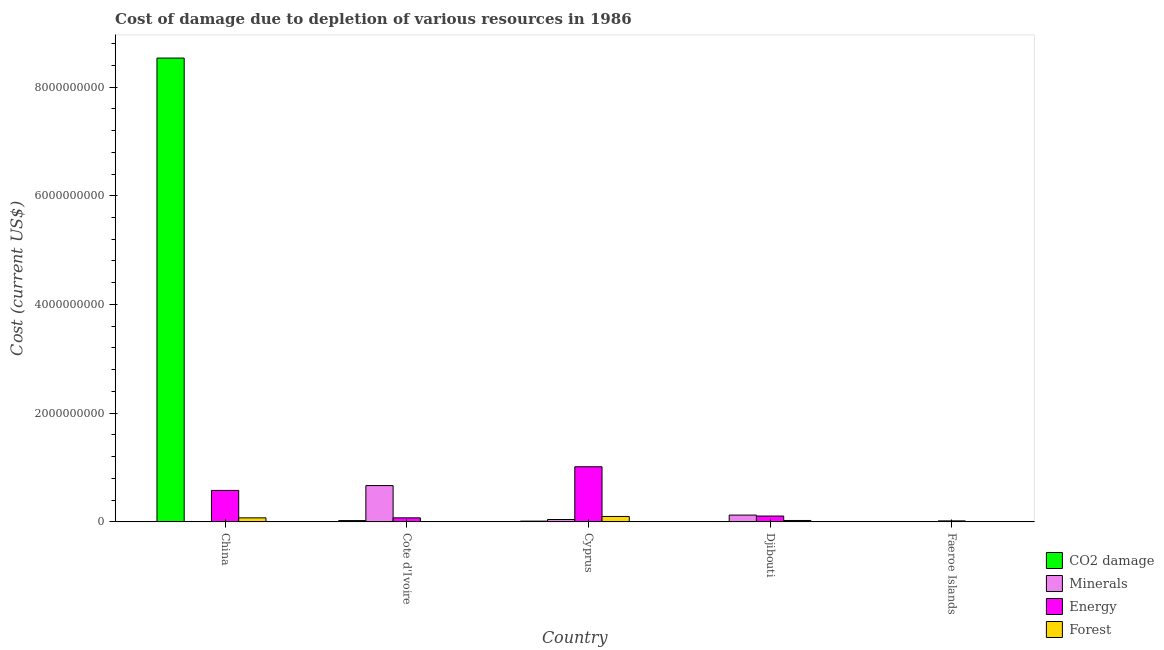How many different coloured bars are there?
Offer a terse response. 4. Are the number of bars on each tick of the X-axis equal?
Make the answer very short. Yes. What is the label of the 2nd group of bars from the left?
Offer a very short reply. Cote d'Ivoire. In how many cases, is the number of bars for a given country not equal to the number of legend labels?
Your answer should be compact. 0. What is the cost of damage due to depletion of minerals in Cote d'Ivoire?
Make the answer very short. 6.69e+08. Across all countries, what is the maximum cost of damage due to depletion of coal?
Your answer should be very brief. 8.53e+09. Across all countries, what is the minimum cost of damage due to depletion of energy?
Keep it short and to the point. 1.89e+07. In which country was the cost of damage due to depletion of minerals maximum?
Your answer should be compact. Cote d'Ivoire. In which country was the cost of damage due to depletion of energy minimum?
Make the answer very short. Faeroe Islands. What is the total cost of damage due to depletion of energy in the graph?
Make the answer very short. 1.80e+09. What is the difference between the cost of damage due to depletion of energy in Cote d'Ivoire and that in Cyprus?
Offer a terse response. -9.40e+08. What is the difference between the cost of damage due to depletion of forests in China and the cost of damage due to depletion of energy in Faeroe Islands?
Your answer should be compact. 5.60e+07. What is the average cost of damage due to depletion of forests per country?
Make the answer very short. 4.16e+07. What is the difference between the cost of damage due to depletion of minerals and cost of damage due to depletion of forests in China?
Offer a terse response. -7.49e+07. What is the ratio of the cost of damage due to depletion of forests in China to that in Faeroe Islands?
Offer a terse response. 11.75. Is the cost of damage due to depletion of energy in China less than that in Faeroe Islands?
Your response must be concise. No. Is the difference between the cost of damage due to depletion of energy in China and Faeroe Islands greater than the difference between the cost of damage due to depletion of coal in China and Faeroe Islands?
Keep it short and to the point. No. What is the difference between the highest and the second highest cost of damage due to depletion of minerals?
Provide a succinct answer. 5.43e+08. What is the difference between the highest and the lowest cost of damage due to depletion of coal?
Offer a terse response. 8.53e+09. In how many countries, is the cost of damage due to depletion of minerals greater than the average cost of damage due to depletion of minerals taken over all countries?
Keep it short and to the point. 1. Is the sum of the cost of damage due to depletion of coal in China and Cyprus greater than the maximum cost of damage due to depletion of forests across all countries?
Ensure brevity in your answer.  Yes. Is it the case that in every country, the sum of the cost of damage due to depletion of coal and cost of damage due to depletion of minerals is greater than the sum of cost of damage due to depletion of energy and cost of damage due to depletion of forests?
Offer a very short reply. No. What does the 1st bar from the left in Djibouti represents?
Your response must be concise. CO2 damage. What does the 2nd bar from the right in China represents?
Keep it short and to the point. Energy. Is it the case that in every country, the sum of the cost of damage due to depletion of coal and cost of damage due to depletion of minerals is greater than the cost of damage due to depletion of energy?
Your answer should be compact. No. How many countries are there in the graph?
Give a very brief answer. 5. What is the difference between two consecutive major ticks on the Y-axis?
Provide a succinct answer. 2.00e+09. Does the graph contain any zero values?
Your response must be concise. No. Where does the legend appear in the graph?
Make the answer very short. Bottom right. What is the title of the graph?
Provide a succinct answer. Cost of damage due to depletion of various resources in 1986 . Does "Finland" appear as one of the legend labels in the graph?
Your response must be concise. No. What is the label or title of the Y-axis?
Offer a terse response. Cost (current US$). What is the Cost (current US$) of CO2 damage in China?
Offer a very short reply. 8.53e+09. What is the Cost (current US$) in Minerals in China?
Keep it short and to the point. 1.22e+04. What is the Cost (current US$) in Energy in China?
Ensure brevity in your answer.  5.79e+08. What is the Cost (current US$) of Forest in China?
Make the answer very short. 7.49e+07. What is the Cost (current US$) in CO2 damage in Cote d'Ivoire?
Offer a terse response. 2.46e+07. What is the Cost (current US$) in Minerals in Cote d'Ivoire?
Offer a terse response. 6.69e+08. What is the Cost (current US$) of Energy in Cote d'Ivoire?
Provide a short and direct response. 7.51e+07. What is the Cost (current US$) of Forest in Cote d'Ivoire?
Your answer should be compact. 6.18e+04. What is the Cost (current US$) of CO2 damage in Cyprus?
Make the answer very short. 1.46e+07. What is the Cost (current US$) in Minerals in Cyprus?
Keep it short and to the point. 4.44e+07. What is the Cost (current US$) in Energy in Cyprus?
Ensure brevity in your answer.  1.01e+09. What is the Cost (current US$) of Forest in Cyprus?
Give a very brief answer. 1.00e+08. What is the Cost (current US$) of CO2 damage in Djibouti?
Make the answer very short. 1.56e+06. What is the Cost (current US$) of Minerals in Djibouti?
Your answer should be very brief. 1.26e+08. What is the Cost (current US$) of Energy in Djibouti?
Offer a very short reply. 1.08e+08. What is the Cost (current US$) in Forest in Djibouti?
Make the answer very short. 2.64e+07. What is the Cost (current US$) in CO2 damage in Faeroe Islands?
Your answer should be very brief. 2.03e+06. What is the Cost (current US$) in Minerals in Faeroe Islands?
Offer a very short reply. 7.62e+05. What is the Cost (current US$) in Energy in Faeroe Islands?
Your answer should be very brief. 1.89e+07. What is the Cost (current US$) of Forest in Faeroe Islands?
Your answer should be very brief. 6.37e+06. Across all countries, what is the maximum Cost (current US$) in CO2 damage?
Give a very brief answer. 8.53e+09. Across all countries, what is the maximum Cost (current US$) in Minerals?
Offer a terse response. 6.69e+08. Across all countries, what is the maximum Cost (current US$) of Energy?
Provide a short and direct response. 1.01e+09. Across all countries, what is the maximum Cost (current US$) in Forest?
Keep it short and to the point. 1.00e+08. Across all countries, what is the minimum Cost (current US$) of CO2 damage?
Your answer should be compact. 1.56e+06. Across all countries, what is the minimum Cost (current US$) of Minerals?
Offer a very short reply. 1.22e+04. Across all countries, what is the minimum Cost (current US$) of Energy?
Offer a very short reply. 1.89e+07. Across all countries, what is the minimum Cost (current US$) in Forest?
Offer a very short reply. 6.18e+04. What is the total Cost (current US$) of CO2 damage in the graph?
Provide a succinct answer. 8.58e+09. What is the total Cost (current US$) of Minerals in the graph?
Offer a terse response. 8.40e+08. What is the total Cost (current US$) of Energy in the graph?
Provide a short and direct response. 1.80e+09. What is the total Cost (current US$) in Forest in the graph?
Your response must be concise. 2.08e+08. What is the difference between the Cost (current US$) in CO2 damage in China and that in Cote d'Ivoire?
Provide a short and direct response. 8.51e+09. What is the difference between the Cost (current US$) in Minerals in China and that in Cote d'Ivoire?
Provide a short and direct response. -6.69e+08. What is the difference between the Cost (current US$) in Energy in China and that in Cote d'Ivoire?
Offer a terse response. 5.04e+08. What is the difference between the Cost (current US$) of Forest in China and that in Cote d'Ivoire?
Provide a succinct answer. 7.48e+07. What is the difference between the Cost (current US$) of CO2 damage in China and that in Cyprus?
Offer a terse response. 8.52e+09. What is the difference between the Cost (current US$) of Minerals in China and that in Cyprus?
Provide a short and direct response. -4.44e+07. What is the difference between the Cost (current US$) in Energy in China and that in Cyprus?
Provide a short and direct response. -4.35e+08. What is the difference between the Cost (current US$) in Forest in China and that in Cyprus?
Give a very brief answer. -2.56e+07. What is the difference between the Cost (current US$) of CO2 damage in China and that in Djibouti?
Provide a succinct answer. 8.53e+09. What is the difference between the Cost (current US$) in Minerals in China and that in Djibouti?
Offer a very short reply. -1.26e+08. What is the difference between the Cost (current US$) in Energy in China and that in Djibouti?
Your answer should be very brief. 4.71e+08. What is the difference between the Cost (current US$) in Forest in China and that in Djibouti?
Provide a short and direct response. 4.85e+07. What is the difference between the Cost (current US$) of CO2 damage in China and that in Faeroe Islands?
Offer a very short reply. 8.53e+09. What is the difference between the Cost (current US$) in Minerals in China and that in Faeroe Islands?
Your response must be concise. -7.50e+05. What is the difference between the Cost (current US$) of Energy in China and that in Faeroe Islands?
Provide a succinct answer. 5.61e+08. What is the difference between the Cost (current US$) in Forest in China and that in Faeroe Islands?
Your answer should be very brief. 6.85e+07. What is the difference between the Cost (current US$) of CO2 damage in Cote d'Ivoire and that in Cyprus?
Make the answer very short. 9.98e+06. What is the difference between the Cost (current US$) of Minerals in Cote d'Ivoire and that in Cyprus?
Ensure brevity in your answer.  6.24e+08. What is the difference between the Cost (current US$) of Energy in Cote d'Ivoire and that in Cyprus?
Ensure brevity in your answer.  -9.40e+08. What is the difference between the Cost (current US$) of Forest in Cote d'Ivoire and that in Cyprus?
Make the answer very short. -1.00e+08. What is the difference between the Cost (current US$) of CO2 damage in Cote d'Ivoire and that in Djibouti?
Make the answer very short. 2.30e+07. What is the difference between the Cost (current US$) in Minerals in Cote d'Ivoire and that in Djibouti?
Provide a short and direct response. 5.43e+08. What is the difference between the Cost (current US$) in Energy in Cote d'Ivoire and that in Djibouti?
Your answer should be very brief. -3.30e+07. What is the difference between the Cost (current US$) in Forest in Cote d'Ivoire and that in Djibouti?
Offer a very short reply. -2.64e+07. What is the difference between the Cost (current US$) of CO2 damage in Cote d'Ivoire and that in Faeroe Islands?
Provide a succinct answer. 2.26e+07. What is the difference between the Cost (current US$) in Minerals in Cote d'Ivoire and that in Faeroe Islands?
Make the answer very short. 6.68e+08. What is the difference between the Cost (current US$) in Energy in Cote d'Ivoire and that in Faeroe Islands?
Keep it short and to the point. 5.62e+07. What is the difference between the Cost (current US$) of Forest in Cote d'Ivoire and that in Faeroe Islands?
Provide a short and direct response. -6.31e+06. What is the difference between the Cost (current US$) of CO2 damage in Cyprus and that in Djibouti?
Offer a very short reply. 1.31e+07. What is the difference between the Cost (current US$) of Minerals in Cyprus and that in Djibouti?
Your answer should be compact. -8.13e+07. What is the difference between the Cost (current US$) of Energy in Cyprus and that in Djibouti?
Offer a terse response. 9.06e+08. What is the difference between the Cost (current US$) in Forest in Cyprus and that in Djibouti?
Your response must be concise. 7.40e+07. What is the difference between the Cost (current US$) of CO2 damage in Cyprus and that in Faeroe Islands?
Offer a very short reply. 1.26e+07. What is the difference between the Cost (current US$) of Minerals in Cyprus and that in Faeroe Islands?
Provide a succinct answer. 4.36e+07. What is the difference between the Cost (current US$) in Energy in Cyprus and that in Faeroe Islands?
Your answer should be very brief. 9.96e+08. What is the difference between the Cost (current US$) of Forest in Cyprus and that in Faeroe Islands?
Offer a very short reply. 9.41e+07. What is the difference between the Cost (current US$) in CO2 damage in Djibouti and that in Faeroe Islands?
Provide a short and direct response. -4.69e+05. What is the difference between the Cost (current US$) in Minerals in Djibouti and that in Faeroe Islands?
Your answer should be compact. 1.25e+08. What is the difference between the Cost (current US$) in Energy in Djibouti and that in Faeroe Islands?
Offer a very short reply. 8.92e+07. What is the difference between the Cost (current US$) in Forest in Djibouti and that in Faeroe Islands?
Offer a terse response. 2.01e+07. What is the difference between the Cost (current US$) in CO2 damage in China and the Cost (current US$) in Minerals in Cote d'Ivoire?
Your response must be concise. 7.86e+09. What is the difference between the Cost (current US$) in CO2 damage in China and the Cost (current US$) in Energy in Cote d'Ivoire?
Your response must be concise. 8.46e+09. What is the difference between the Cost (current US$) in CO2 damage in China and the Cost (current US$) in Forest in Cote d'Ivoire?
Offer a very short reply. 8.53e+09. What is the difference between the Cost (current US$) in Minerals in China and the Cost (current US$) in Energy in Cote d'Ivoire?
Your answer should be compact. -7.51e+07. What is the difference between the Cost (current US$) of Minerals in China and the Cost (current US$) of Forest in Cote d'Ivoire?
Provide a succinct answer. -4.96e+04. What is the difference between the Cost (current US$) of Energy in China and the Cost (current US$) of Forest in Cote d'Ivoire?
Provide a short and direct response. 5.79e+08. What is the difference between the Cost (current US$) in CO2 damage in China and the Cost (current US$) in Minerals in Cyprus?
Ensure brevity in your answer.  8.49e+09. What is the difference between the Cost (current US$) in CO2 damage in China and the Cost (current US$) in Energy in Cyprus?
Offer a terse response. 7.52e+09. What is the difference between the Cost (current US$) of CO2 damage in China and the Cost (current US$) of Forest in Cyprus?
Offer a very short reply. 8.43e+09. What is the difference between the Cost (current US$) of Minerals in China and the Cost (current US$) of Energy in Cyprus?
Ensure brevity in your answer.  -1.01e+09. What is the difference between the Cost (current US$) in Minerals in China and the Cost (current US$) in Forest in Cyprus?
Give a very brief answer. -1.00e+08. What is the difference between the Cost (current US$) in Energy in China and the Cost (current US$) in Forest in Cyprus?
Your answer should be very brief. 4.79e+08. What is the difference between the Cost (current US$) of CO2 damage in China and the Cost (current US$) of Minerals in Djibouti?
Make the answer very short. 8.41e+09. What is the difference between the Cost (current US$) of CO2 damage in China and the Cost (current US$) of Energy in Djibouti?
Give a very brief answer. 8.42e+09. What is the difference between the Cost (current US$) of CO2 damage in China and the Cost (current US$) of Forest in Djibouti?
Your answer should be compact. 8.51e+09. What is the difference between the Cost (current US$) of Minerals in China and the Cost (current US$) of Energy in Djibouti?
Provide a succinct answer. -1.08e+08. What is the difference between the Cost (current US$) of Minerals in China and the Cost (current US$) of Forest in Djibouti?
Your response must be concise. -2.64e+07. What is the difference between the Cost (current US$) of Energy in China and the Cost (current US$) of Forest in Djibouti?
Your response must be concise. 5.53e+08. What is the difference between the Cost (current US$) of CO2 damage in China and the Cost (current US$) of Minerals in Faeroe Islands?
Offer a very short reply. 8.53e+09. What is the difference between the Cost (current US$) in CO2 damage in China and the Cost (current US$) in Energy in Faeroe Islands?
Give a very brief answer. 8.51e+09. What is the difference between the Cost (current US$) of CO2 damage in China and the Cost (current US$) of Forest in Faeroe Islands?
Your answer should be compact. 8.53e+09. What is the difference between the Cost (current US$) of Minerals in China and the Cost (current US$) of Energy in Faeroe Islands?
Your answer should be very brief. -1.89e+07. What is the difference between the Cost (current US$) of Minerals in China and the Cost (current US$) of Forest in Faeroe Islands?
Your response must be concise. -6.36e+06. What is the difference between the Cost (current US$) in Energy in China and the Cost (current US$) in Forest in Faeroe Islands?
Offer a terse response. 5.73e+08. What is the difference between the Cost (current US$) in CO2 damage in Cote d'Ivoire and the Cost (current US$) in Minerals in Cyprus?
Provide a succinct answer. -1.98e+07. What is the difference between the Cost (current US$) of CO2 damage in Cote d'Ivoire and the Cost (current US$) of Energy in Cyprus?
Ensure brevity in your answer.  -9.90e+08. What is the difference between the Cost (current US$) in CO2 damage in Cote d'Ivoire and the Cost (current US$) in Forest in Cyprus?
Offer a very short reply. -7.59e+07. What is the difference between the Cost (current US$) of Minerals in Cote d'Ivoire and the Cost (current US$) of Energy in Cyprus?
Your response must be concise. -3.46e+08. What is the difference between the Cost (current US$) of Minerals in Cote d'Ivoire and the Cost (current US$) of Forest in Cyprus?
Your answer should be compact. 5.68e+08. What is the difference between the Cost (current US$) in Energy in Cote d'Ivoire and the Cost (current US$) in Forest in Cyprus?
Your answer should be compact. -2.54e+07. What is the difference between the Cost (current US$) of CO2 damage in Cote d'Ivoire and the Cost (current US$) of Minerals in Djibouti?
Your answer should be compact. -1.01e+08. What is the difference between the Cost (current US$) in CO2 damage in Cote d'Ivoire and the Cost (current US$) in Energy in Djibouti?
Provide a short and direct response. -8.36e+07. What is the difference between the Cost (current US$) of CO2 damage in Cote d'Ivoire and the Cost (current US$) of Forest in Djibouti?
Your response must be concise. -1.82e+06. What is the difference between the Cost (current US$) of Minerals in Cote d'Ivoire and the Cost (current US$) of Energy in Djibouti?
Offer a very short reply. 5.61e+08. What is the difference between the Cost (current US$) of Minerals in Cote d'Ivoire and the Cost (current US$) of Forest in Djibouti?
Ensure brevity in your answer.  6.42e+08. What is the difference between the Cost (current US$) of Energy in Cote d'Ivoire and the Cost (current US$) of Forest in Djibouti?
Make the answer very short. 4.87e+07. What is the difference between the Cost (current US$) of CO2 damage in Cote d'Ivoire and the Cost (current US$) of Minerals in Faeroe Islands?
Your response must be concise. 2.38e+07. What is the difference between the Cost (current US$) in CO2 damage in Cote d'Ivoire and the Cost (current US$) in Energy in Faeroe Islands?
Keep it short and to the point. 5.66e+06. What is the difference between the Cost (current US$) of CO2 damage in Cote d'Ivoire and the Cost (current US$) of Forest in Faeroe Islands?
Provide a short and direct response. 1.82e+07. What is the difference between the Cost (current US$) in Minerals in Cote d'Ivoire and the Cost (current US$) in Energy in Faeroe Islands?
Your answer should be very brief. 6.50e+08. What is the difference between the Cost (current US$) in Minerals in Cote d'Ivoire and the Cost (current US$) in Forest in Faeroe Islands?
Give a very brief answer. 6.62e+08. What is the difference between the Cost (current US$) of Energy in Cote d'Ivoire and the Cost (current US$) of Forest in Faeroe Islands?
Your response must be concise. 6.87e+07. What is the difference between the Cost (current US$) in CO2 damage in Cyprus and the Cost (current US$) in Minerals in Djibouti?
Provide a succinct answer. -1.11e+08. What is the difference between the Cost (current US$) in CO2 damage in Cyprus and the Cost (current US$) in Energy in Djibouti?
Provide a short and direct response. -9.35e+07. What is the difference between the Cost (current US$) of CO2 damage in Cyprus and the Cost (current US$) of Forest in Djibouti?
Make the answer very short. -1.18e+07. What is the difference between the Cost (current US$) of Minerals in Cyprus and the Cost (current US$) of Energy in Djibouti?
Your response must be concise. -6.38e+07. What is the difference between the Cost (current US$) of Minerals in Cyprus and the Cost (current US$) of Forest in Djibouti?
Give a very brief answer. 1.80e+07. What is the difference between the Cost (current US$) of Energy in Cyprus and the Cost (current US$) of Forest in Djibouti?
Make the answer very short. 9.88e+08. What is the difference between the Cost (current US$) in CO2 damage in Cyprus and the Cost (current US$) in Minerals in Faeroe Islands?
Provide a succinct answer. 1.39e+07. What is the difference between the Cost (current US$) in CO2 damage in Cyprus and the Cost (current US$) in Energy in Faeroe Islands?
Provide a succinct answer. -4.32e+06. What is the difference between the Cost (current US$) in CO2 damage in Cyprus and the Cost (current US$) in Forest in Faeroe Islands?
Provide a succinct answer. 8.25e+06. What is the difference between the Cost (current US$) of Minerals in Cyprus and the Cost (current US$) of Energy in Faeroe Islands?
Offer a terse response. 2.54e+07. What is the difference between the Cost (current US$) in Minerals in Cyprus and the Cost (current US$) in Forest in Faeroe Islands?
Make the answer very short. 3.80e+07. What is the difference between the Cost (current US$) in Energy in Cyprus and the Cost (current US$) in Forest in Faeroe Islands?
Keep it short and to the point. 1.01e+09. What is the difference between the Cost (current US$) in CO2 damage in Djibouti and the Cost (current US$) in Minerals in Faeroe Islands?
Offer a terse response. 7.96e+05. What is the difference between the Cost (current US$) in CO2 damage in Djibouti and the Cost (current US$) in Energy in Faeroe Islands?
Keep it short and to the point. -1.74e+07. What is the difference between the Cost (current US$) of CO2 damage in Djibouti and the Cost (current US$) of Forest in Faeroe Islands?
Offer a very short reply. -4.82e+06. What is the difference between the Cost (current US$) of Minerals in Djibouti and the Cost (current US$) of Energy in Faeroe Islands?
Give a very brief answer. 1.07e+08. What is the difference between the Cost (current US$) of Minerals in Djibouti and the Cost (current US$) of Forest in Faeroe Islands?
Offer a very short reply. 1.19e+08. What is the difference between the Cost (current US$) in Energy in Djibouti and the Cost (current US$) in Forest in Faeroe Islands?
Your answer should be very brief. 1.02e+08. What is the average Cost (current US$) of CO2 damage per country?
Make the answer very short. 1.72e+09. What is the average Cost (current US$) of Minerals per country?
Make the answer very short. 1.68e+08. What is the average Cost (current US$) in Energy per country?
Make the answer very short. 3.59e+08. What is the average Cost (current US$) in Forest per country?
Give a very brief answer. 4.16e+07. What is the difference between the Cost (current US$) in CO2 damage and Cost (current US$) in Minerals in China?
Your answer should be very brief. 8.53e+09. What is the difference between the Cost (current US$) of CO2 damage and Cost (current US$) of Energy in China?
Your answer should be compact. 7.95e+09. What is the difference between the Cost (current US$) of CO2 damage and Cost (current US$) of Forest in China?
Make the answer very short. 8.46e+09. What is the difference between the Cost (current US$) in Minerals and Cost (current US$) in Energy in China?
Provide a succinct answer. -5.79e+08. What is the difference between the Cost (current US$) of Minerals and Cost (current US$) of Forest in China?
Ensure brevity in your answer.  -7.49e+07. What is the difference between the Cost (current US$) in Energy and Cost (current US$) in Forest in China?
Your response must be concise. 5.05e+08. What is the difference between the Cost (current US$) in CO2 damage and Cost (current US$) in Minerals in Cote d'Ivoire?
Your answer should be very brief. -6.44e+08. What is the difference between the Cost (current US$) in CO2 damage and Cost (current US$) in Energy in Cote d'Ivoire?
Provide a short and direct response. -5.05e+07. What is the difference between the Cost (current US$) of CO2 damage and Cost (current US$) of Forest in Cote d'Ivoire?
Your answer should be compact. 2.45e+07. What is the difference between the Cost (current US$) of Minerals and Cost (current US$) of Energy in Cote d'Ivoire?
Ensure brevity in your answer.  5.94e+08. What is the difference between the Cost (current US$) in Minerals and Cost (current US$) in Forest in Cote d'Ivoire?
Offer a very short reply. 6.69e+08. What is the difference between the Cost (current US$) of Energy and Cost (current US$) of Forest in Cote d'Ivoire?
Keep it short and to the point. 7.51e+07. What is the difference between the Cost (current US$) of CO2 damage and Cost (current US$) of Minerals in Cyprus?
Offer a terse response. -2.98e+07. What is the difference between the Cost (current US$) in CO2 damage and Cost (current US$) in Energy in Cyprus?
Your answer should be compact. -1.00e+09. What is the difference between the Cost (current US$) in CO2 damage and Cost (current US$) in Forest in Cyprus?
Ensure brevity in your answer.  -8.58e+07. What is the difference between the Cost (current US$) of Minerals and Cost (current US$) of Energy in Cyprus?
Provide a succinct answer. -9.70e+08. What is the difference between the Cost (current US$) of Minerals and Cost (current US$) of Forest in Cyprus?
Your response must be concise. -5.61e+07. What is the difference between the Cost (current US$) of Energy and Cost (current US$) of Forest in Cyprus?
Offer a terse response. 9.14e+08. What is the difference between the Cost (current US$) in CO2 damage and Cost (current US$) in Minerals in Djibouti?
Make the answer very short. -1.24e+08. What is the difference between the Cost (current US$) in CO2 damage and Cost (current US$) in Energy in Djibouti?
Offer a very short reply. -1.07e+08. What is the difference between the Cost (current US$) of CO2 damage and Cost (current US$) of Forest in Djibouti?
Provide a short and direct response. -2.49e+07. What is the difference between the Cost (current US$) of Minerals and Cost (current US$) of Energy in Djibouti?
Keep it short and to the point. 1.76e+07. What is the difference between the Cost (current US$) in Minerals and Cost (current US$) in Forest in Djibouti?
Offer a very short reply. 9.93e+07. What is the difference between the Cost (current US$) of Energy and Cost (current US$) of Forest in Djibouti?
Your response must be concise. 8.17e+07. What is the difference between the Cost (current US$) in CO2 damage and Cost (current US$) in Minerals in Faeroe Islands?
Provide a succinct answer. 1.26e+06. What is the difference between the Cost (current US$) in CO2 damage and Cost (current US$) in Energy in Faeroe Islands?
Your answer should be very brief. -1.69e+07. What is the difference between the Cost (current US$) of CO2 damage and Cost (current US$) of Forest in Faeroe Islands?
Your answer should be compact. -4.35e+06. What is the difference between the Cost (current US$) of Minerals and Cost (current US$) of Energy in Faeroe Islands?
Your response must be concise. -1.82e+07. What is the difference between the Cost (current US$) in Minerals and Cost (current US$) in Forest in Faeroe Islands?
Provide a short and direct response. -5.61e+06. What is the difference between the Cost (current US$) of Energy and Cost (current US$) of Forest in Faeroe Islands?
Give a very brief answer. 1.26e+07. What is the ratio of the Cost (current US$) in CO2 damage in China to that in Cote d'Ivoire?
Your answer should be compact. 346.78. What is the ratio of the Cost (current US$) of Minerals in China to that in Cote d'Ivoire?
Ensure brevity in your answer.  0. What is the ratio of the Cost (current US$) in Energy in China to that in Cote d'Ivoire?
Give a very brief answer. 7.71. What is the ratio of the Cost (current US$) in Forest in China to that in Cote d'Ivoire?
Your answer should be very brief. 1212.23. What is the ratio of the Cost (current US$) in CO2 damage in China to that in Cyprus?
Your response must be concise. 583.47. What is the ratio of the Cost (current US$) in Energy in China to that in Cyprus?
Provide a short and direct response. 0.57. What is the ratio of the Cost (current US$) of Forest in China to that in Cyprus?
Provide a short and direct response. 0.75. What is the ratio of the Cost (current US$) of CO2 damage in China to that in Djibouti?
Provide a short and direct response. 5477.8. What is the ratio of the Cost (current US$) in Minerals in China to that in Djibouti?
Offer a terse response. 0. What is the ratio of the Cost (current US$) of Energy in China to that in Djibouti?
Keep it short and to the point. 5.36. What is the ratio of the Cost (current US$) in Forest in China to that in Djibouti?
Ensure brevity in your answer.  2.83. What is the ratio of the Cost (current US$) in CO2 damage in China to that in Faeroe Islands?
Ensure brevity in your answer.  4210.54. What is the ratio of the Cost (current US$) in Minerals in China to that in Faeroe Islands?
Make the answer very short. 0.02. What is the ratio of the Cost (current US$) in Energy in China to that in Faeroe Islands?
Your response must be concise. 30.59. What is the ratio of the Cost (current US$) in Forest in China to that in Faeroe Islands?
Offer a very short reply. 11.75. What is the ratio of the Cost (current US$) of CO2 damage in Cote d'Ivoire to that in Cyprus?
Offer a very short reply. 1.68. What is the ratio of the Cost (current US$) of Minerals in Cote d'Ivoire to that in Cyprus?
Ensure brevity in your answer.  15.06. What is the ratio of the Cost (current US$) in Energy in Cote d'Ivoire to that in Cyprus?
Provide a succinct answer. 0.07. What is the ratio of the Cost (current US$) in Forest in Cote d'Ivoire to that in Cyprus?
Provide a succinct answer. 0. What is the ratio of the Cost (current US$) in CO2 damage in Cote d'Ivoire to that in Djibouti?
Keep it short and to the point. 15.8. What is the ratio of the Cost (current US$) in Minerals in Cote d'Ivoire to that in Djibouti?
Give a very brief answer. 5.32. What is the ratio of the Cost (current US$) in Energy in Cote d'Ivoire to that in Djibouti?
Provide a succinct answer. 0.69. What is the ratio of the Cost (current US$) of Forest in Cote d'Ivoire to that in Djibouti?
Your response must be concise. 0. What is the ratio of the Cost (current US$) in CO2 damage in Cote d'Ivoire to that in Faeroe Islands?
Your answer should be compact. 12.14. What is the ratio of the Cost (current US$) of Minerals in Cote d'Ivoire to that in Faeroe Islands?
Your answer should be very brief. 877.67. What is the ratio of the Cost (current US$) of Energy in Cote d'Ivoire to that in Faeroe Islands?
Provide a short and direct response. 3.97. What is the ratio of the Cost (current US$) of Forest in Cote d'Ivoire to that in Faeroe Islands?
Offer a very short reply. 0.01. What is the ratio of the Cost (current US$) of CO2 damage in Cyprus to that in Djibouti?
Keep it short and to the point. 9.39. What is the ratio of the Cost (current US$) of Minerals in Cyprus to that in Djibouti?
Ensure brevity in your answer.  0.35. What is the ratio of the Cost (current US$) of Energy in Cyprus to that in Djibouti?
Offer a very short reply. 9.38. What is the ratio of the Cost (current US$) of Forest in Cyprus to that in Djibouti?
Offer a terse response. 3.8. What is the ratio of the Cost (current US$) of CO2 damage in Cyprus to that in Faeroe Islands?
Make the answer very short. 7.22. What is the ratio of the Cost (current US$) of Minerals in Cyprus to that in Faeroe Islands?
Your answer should be compact. 58.27. What is the ratio of the Cost (current US$) of Energy in Cyprus to that in Faeroe Islands?
Make the answer very short. 53.56. What is the ratio of the Cost (current US$) of Forest in Cyprus to that in Faeroe Islands?
Provide a short and direct response. 15.77. What is the ratio of the Cost (current US$) in CO2 damage in Djibouti to that in Faeroe Islands?
Provide a succinct answer. 0.77. What is the ratio of the Cost (current US$) in Minerals in Djibouti to that in Faeroe Islands?
Ensure brevity in your answer.  165.03. What is the ratio of the Cost (current US$) in Energy in Djibouti to that in Faeroe Islands?
Your answer should be very brief. 5.71. What is the ratio of the Cost (current US$) of Forest in Djibouti to that in Faeroe Islands?
Give a very brief answer. 4.15. What is the difference between the highest and the second highest Cost (current US$) of CO2 damage?
Provide a short and direct response. 8.51e+09. What is the difference between the highest and the second highest Cost (current US$) of Minerals?
Offer a terse response. 5.43e+08. What is the difference between the highest and the second highest Cost (current US$) of Energy?
Provide a short and direct response. 4.35e+08. What is the difference between the highest and the second highest Cost (current US$) of Forest?
Keep it short and to the point. 2.56e+07. What is the difference between the highest and the lowest Cost (current US$) in CO2 damage?
Provide a short and direct response. 8.53e+09. What is the difference between the highest and the lowest Cost (current US$) in Minerals?
Your response must be concise. 6.69e+08. What is the difference between the highest and the lowest Cost (current US$) in Energy?
Your answer should be compact. 9.96e+08. What is the difference between the highest and the lowest Cost (current US$) in Forest?
Offer a terse response. 1.00e+08. 